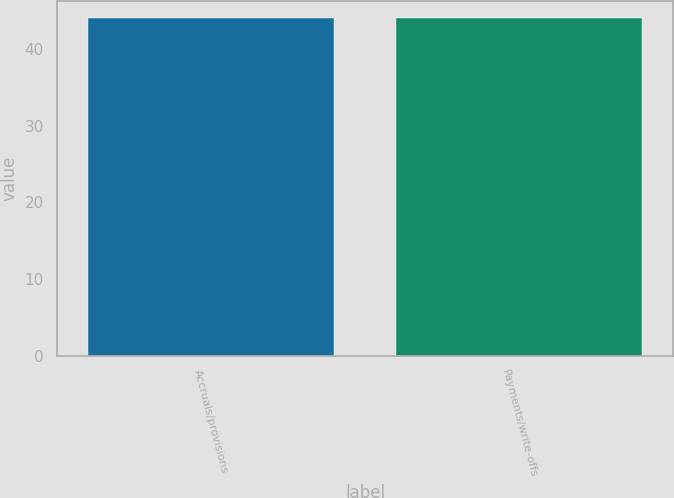Convert chart. <chart><loc_0><loc_0><loc_500><loc_500><bar_chart><fcel>Accruals/provisions<fcel>Payments/write-offs<nl><fcel>44<fcel>44.1<nl></chart> 